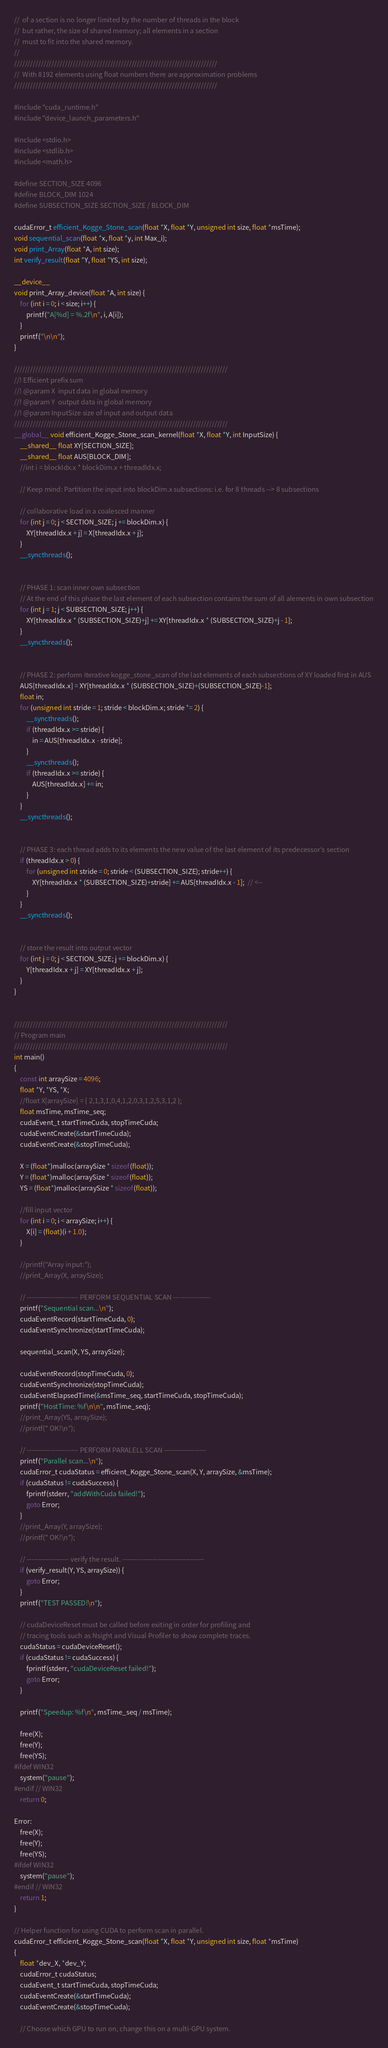<code> <loc_0><loc_0><loc_500><loc_500><_Cuda_>//	of a section is no longer limited by the number of threads in the block
//	but rather, the size of shared memory; all elements in a section
//	must to fit into the shared memory.
//
////////////////////////////////////////////////////////////////////////////
//	With 8192 elements using float numbers there are approximation problems 
////////////////////////////////////////////////////////////////////////////

#include "cuda_runtime.h"
#include "device_launch_parameters.h"

#include <stdio.h>
#include <stdlib.h>
#include <math.h>

#define SECTION_SIZE 4096
#define BLOCK_DIM 1024
#define SUBSECTION_SIZE SECTION_SIZE / BLOCK_DIM

cudaError_t efficient_Kogge_Stone_scan(float *X, float *Y, unsigned int size, float *msTime);
void sequential_scan(float *x, float *y, int Max_i);
void print_Array(float *A, int size);
int verify_result(float *Y, float *YS, int size);

__device__
void print_Array_device(float *A, int size) {
	for (int i = 0; i < size; i++) {
		printf("A[%d] = %.2f\n", i, A[i]);
	}
	printf("\n\n");
}

////////////////////////////////////////////////////////////////////////////////
//! Efficient prefix sum 
//! @param X  input data in global memory
//! @param Y  output data in global memory
//! @param InputSize size of input and output data
////////////////////////////////////////////////////////////////////////////////
__global__ void efficient_Kogge_Stone_scan_kernel(float *X, float *Y, int InputSize) {
	__shared__ float XY[SECTION_SIZE];
	__shared__ float AUS[BLOCK_DIM];
	//int i = blockIdx.x * blockDim.x + threadIdx.x;

	// Keep mind: Partition the input into blockDim.x subsections: i.e. for 8 threads --> 8 subsections

	// collaborative load in a coalesced manner
	for (int j = 0; j < SECTION_SIZE; j += blockDim.x) {
		XY[threadIdx.x + j] = X[threadIdx.x + j];
	}
	__syncthreads();


	// PHASE 1: scan inner own subsection
	// At the end of this phase the last element of each subsection contains the sum of all alements in own subsection
	for (int j = 1; j < SUBSECTION_SIZE; j++) {
		XY[threadIdx.x * (SUBSECTION_SIZE)+j] += XY[threadIdx.x * (SUBSECTION_SIZE)+j - 1];
	}
	__syncthreads();


	// PHASE 2: perform iterative kogge_stone_scan of the last elements of each subsections of XY loaded first in AUS
	AUS[threadIdx.x] = XY[threadIdx.x * (SUBSECTION_SIZE)+(SUBSECTION_SIZE)-1];
	float in;
	for (unsigned int stride = 1; stride < blockDim.x; stride *= 2) {
		__syncthreads();
		if (threadIdx.x >= stride) {
			in = AUS[threadIdx.x - stride];
		}
		__syncthreads();
		if (threadIdx.x >= stride) {
			AUS[threadIdx.x] += in;
		}
	}
	__syncthreads();


	// PHASE 3: each thread adds to its elements the new value of the last element of its predecessor's section
	if (threadIdx.x > 0) {
		for (unsigned int stride = 0; stride < (SUBSECTION_SIZE); stride++) {
			XY[threadIdx.x * (SUBSECTION_SIZE)+stride] += AUS[threadIdx.x - 1];  // <--
		}
	}
	__syncthreads();


	// store the result into output vector
	for (int j = 0; j < SECTION_SIZE; j += blockDim.x) {
		Y[threadIdx.x + j] = XY[threadIdx.x + j];
	}
}


////////////////////////////////////////////////////////////////////////////////
// Program main
////////////////////////////////////////////////////////////////////////////////
int main()
{
	const int arraySize = 4096;
	float *Y, *YS, *X;
	//float X[arraySize] = { 2,1,3,1,0,4,1,2,0,3,1,2,5,3,1,2 };
	float msTime, msTime_seq;
	cudaEvent_t startTimeCuda, stopTimeCuda;
	cudaEventCreate(&startTimeCuda);
	cudaEventCreate(&stopTimeCuda);

	X = (float*)malloc(arraySize * sizeof(float));
	Y = (float*)malloc(arraySize * sizeof(float));
	YS = (float*)malloc(arraySize * sizeof(float));

	//fill input vector
	for (int i = 0; i < arraySize; i++) {
		X[i] = (float)(i + 1.0);
	}

	//printf("Array input:");
	//print_Array(X, arraySize);

	// ---------------------- PERFORM SEQUENTIAL SCAN ----------------
	printf("Sequential scan...\n");
	cudaEventRecord(startTimeCuda, 0);
	cudaEventSynchronize(startTimeCuda);

	sequential_scan(X, YS, arraySize);

	cudaEventRecord(stopTimeCuda, 0);
	cudaEventSynchronize(stopTimeCuda);
	cudaEventElapsedTime(&msTime_seq, startTimeCuda, stopTimeCuda);
	printf("HostTime: %f\n\n", msTime_seq);
	//print_Array(YS, arraySize);
	//printf(" OK!\n");

	// ---------------------- PERFORM PARALELL SCAN ------------------
	printf("Parallel scan...\n");
	cudaError_t cudaStatus = efficient_Kogge_Stone_scan(X, Y, arraySize, &msTime);
	if (cudaStatus != cudaSuccess) {
		fprintf(stderr, "addWithCuda failed!");
		goto Error;
	}
	//print_Array(Y, arraySize);
	//printf(" OK!\n");

	// ------------------ verify the result. -----------------------------------
	if (verify_result(Y, YS, arraySize)) {
		goto Error;
	}
	printf("TEST PASSED!\n");

	// cudaDeviceReset must be called before exiting in order for profiling and
	// tracing tools such as Nsight and Visual Profiler to show complete traces.
	cudaStatus = cudaDeviceReset();
	if (cudaStatus != cudaSuccess) {
		fprintf(stderr, "cudaDeviceReset failed!");
		goto Error;
	}

	printf("Speedup: %f\n", msTime_seq / msTime);

	free(X);
	free(Y);
	free(YS);
#ifdef WIN32
	system("pause");
#endif // WIN32
	return 0;

Error:
	free(X);
	free(Y);
	free(YS);
#ifdef WIN32
	system("pause");
#endif // WIN32
	return 1;
}

// Helper function for using CUDA to perform scan in parallel.
cudaError_t efficient_Kogge_Stone_scan(float *X, float *Y, unsigned int size, float *msTime)
{
	float *dev_X, *dev_Y;
	cudaError_t cudaStatus;
	cudaEvent_t startTimeCuda, stopTimeCuda;
	cudaEventCreate(&startTimeCuda);
	cudaEventCreate(&stopTimeCuda);

	// Choose which GPU to run on, change this on a multi-GPU system.</code> 